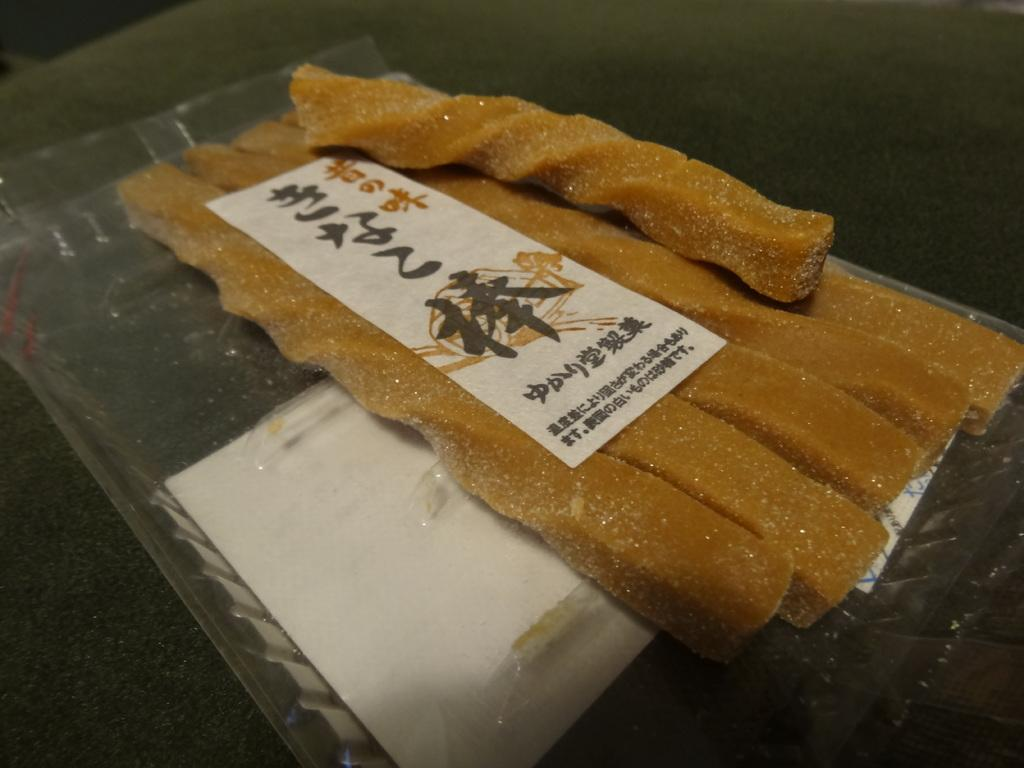What type of items can be seen in the image? There are eatables in the image. Where are the eatables located? The eatables are placed on an object. What type of fiction is the actor reading to the boy in the image? There is no actor, boy, or fiction present in the image; it only features eatables placed on an object. 